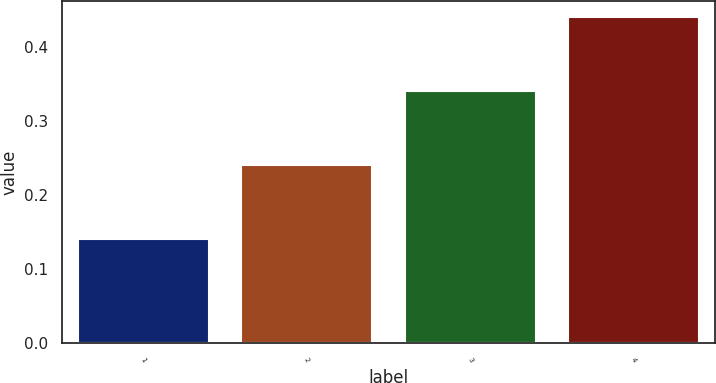Convert chart. <chart><loc_0><loc_0><loc_500><loc_500><bar_chart><fcel>1<fcel>2<fcel>3<fcel>4<nl><fcel>0.14<fcel>0.24<fcel>0.34<fcel>0.44<nl></chart> 